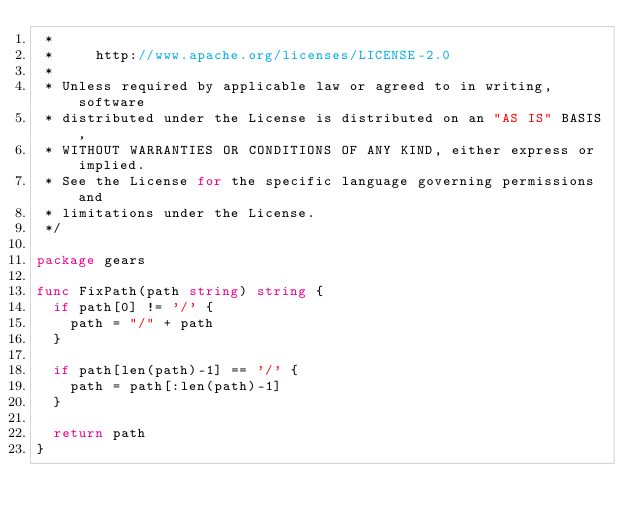Convert code to text. <code><loc_0><loc_0><loc_500><loc_500><_Go_> *
 *     http://www.apache.org/licenses/LICENSE-2.0
 *
 * Unless required by applicable law or agreed to in writing, software
 * distributed under the License is distributed on an "AS IS" BASIS,
 * WITHOUT WARRANTIES OR CONDITIONS OF ANY KIND, either express or implied.
 * See the License for the specific language governing permissions and
 * limitations under the License.
 */

package gears

func FixPath(path string) string {
	if path[0] != '/' {
		path = "/" + path
	}

	if path[len(path)-1] == '/' {
		path = path[:len(path)-1]
	}

	return path
}
</code> 